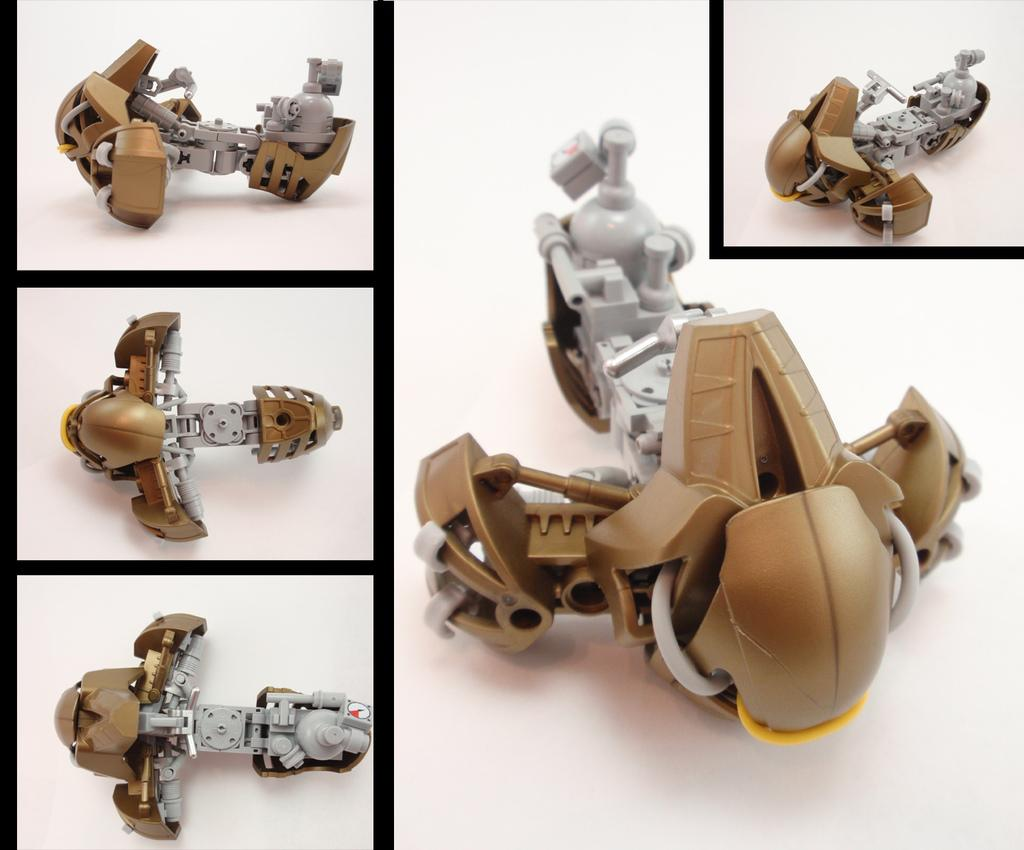What type of artwork is depicted in the image? The image is a collage. What objects can be seen in the collage? There are toys in the image. What scent can be detected from the toys in the image? There is no information about the scent of the toys in the image, as the facts provided only mention their presence in the collage. 